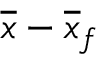<formula> <loc_0><loc_0><loc_500><loc_500>\overline { x } - \overline { x } _ { f }</formula> 